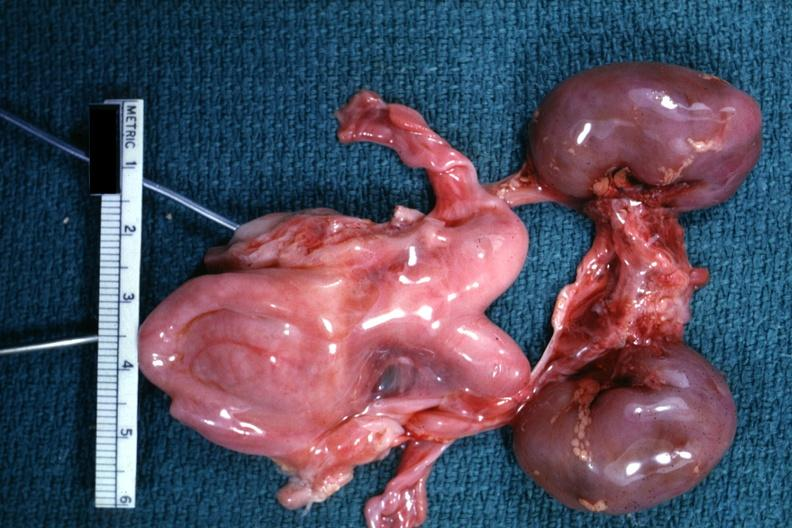s abruption present?
Answer the question using a single word or phrase. No 